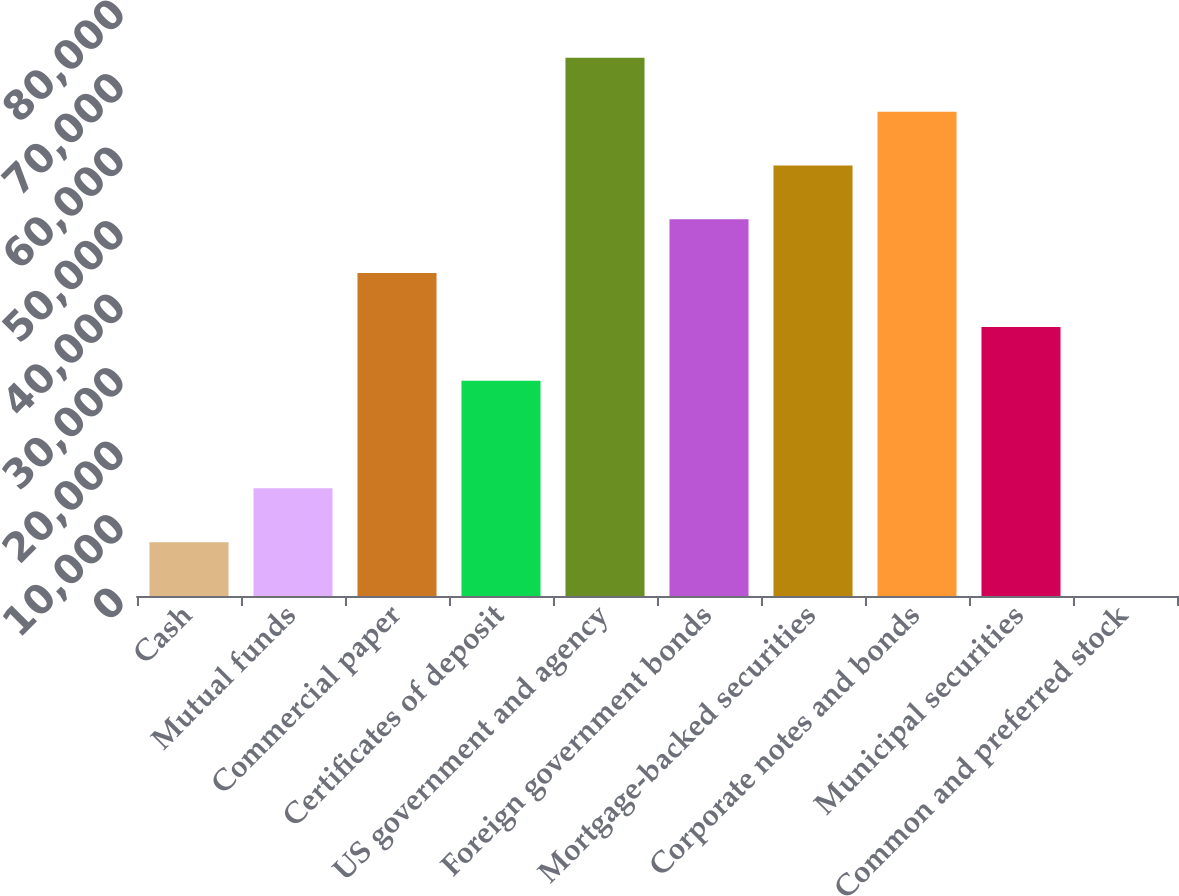Convert chart. <chart><loc_0><loc_0><loc_500><loc_500><bar_chart><fcel>Cash<fcel>Mutual funds<fcel>Commercial paper<fcel>Certificates of deposit<fcel>US government and agency<fcel>Foreign government bonds<fcel>Mortgage-backed securities<fcel>Corporate notes and bonds<fcel>Municipal securities<fcel>Common and preferred stock<nl><fcel>7322<fcel>14643.8<fcel>43930.9<fcel>29287.3<fcel>73218<fcel>51252.7<fcel>58574.5<fcel>65896.2<fcel>36609.1<fcel>0.22<nl></chart> 